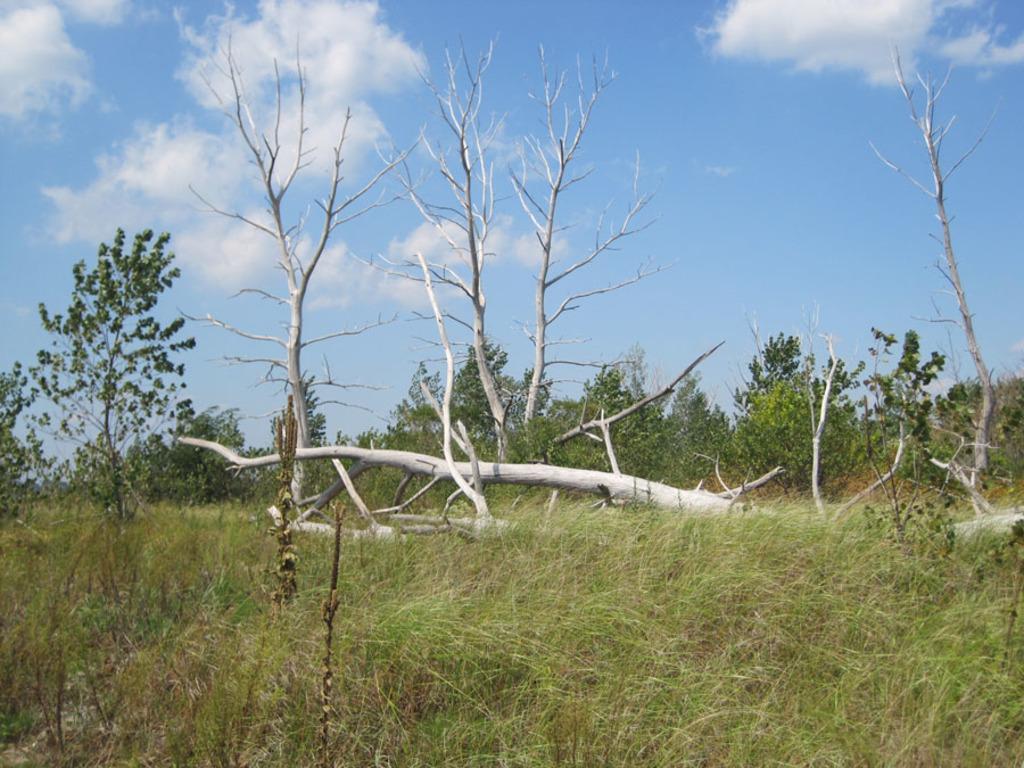Can you describe this image briefly? In this picture there is greenery in the center of the image and there is sky at the top side of the image. 